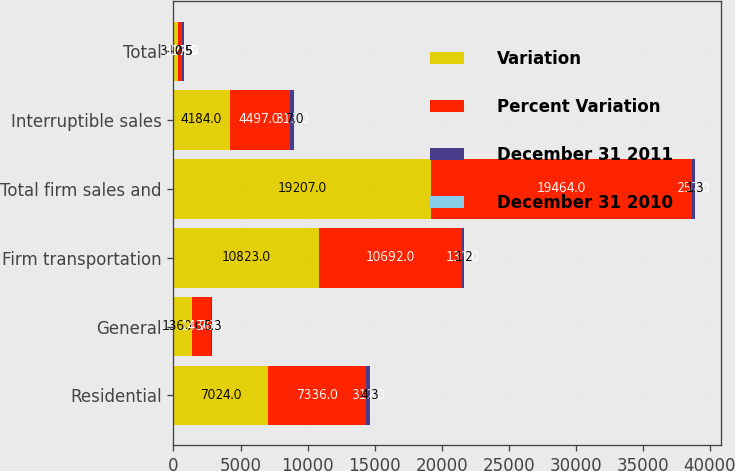Convert chart. <chart><loc_0><loc_0><loc_500><loc_500><stacked_bar_chart><ecel><fcel>Residential<fcel>General<fcel>Firm transportation<fcel>Total firm sales and<fcel>Interruptible sales<fcel>Total<nl><fcel>Variation<fcel>7024<fcel>1360<fcel>10823<fcel>19207<fcel>4184<fcel>312.5<nl><fcel>Percent Variation<fcel>7336<fcel>1436<fcel>10692<fcel>19464<fcel>4497<fcel>312.5<nl><fcel>December 31 2011<fcel>312<fcel>76<fcel>131<fcel>257<fcel>313<fcel>128<nl><fcel>December 31 2010<fcel>4.3<fcel>5.3<fcel>1.2<fcel>1.3<fcel>7<fcel>0.5<nl></chart> 